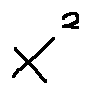Convert formula to latex. <formula><loc_0><loc_0><loc_500><loc_500>x ^ { 2 }</formula> 